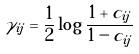Convert formula to latex. <formula><loc_0><loc_0><loc_500><loc_500>\gamma _ { i j } = \frac { 1 } { 2 } \log \frac { 1 + c _ { i j } } { 1 - c _ { i j } }</formula> 